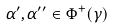<formula> <loc_0><loc_0><loc_500><loc_500>\alpha ^ { \prime } , \alpha ^ { \prime \prime } \in \Phi ^ { + } ( \gamma )</formula> 